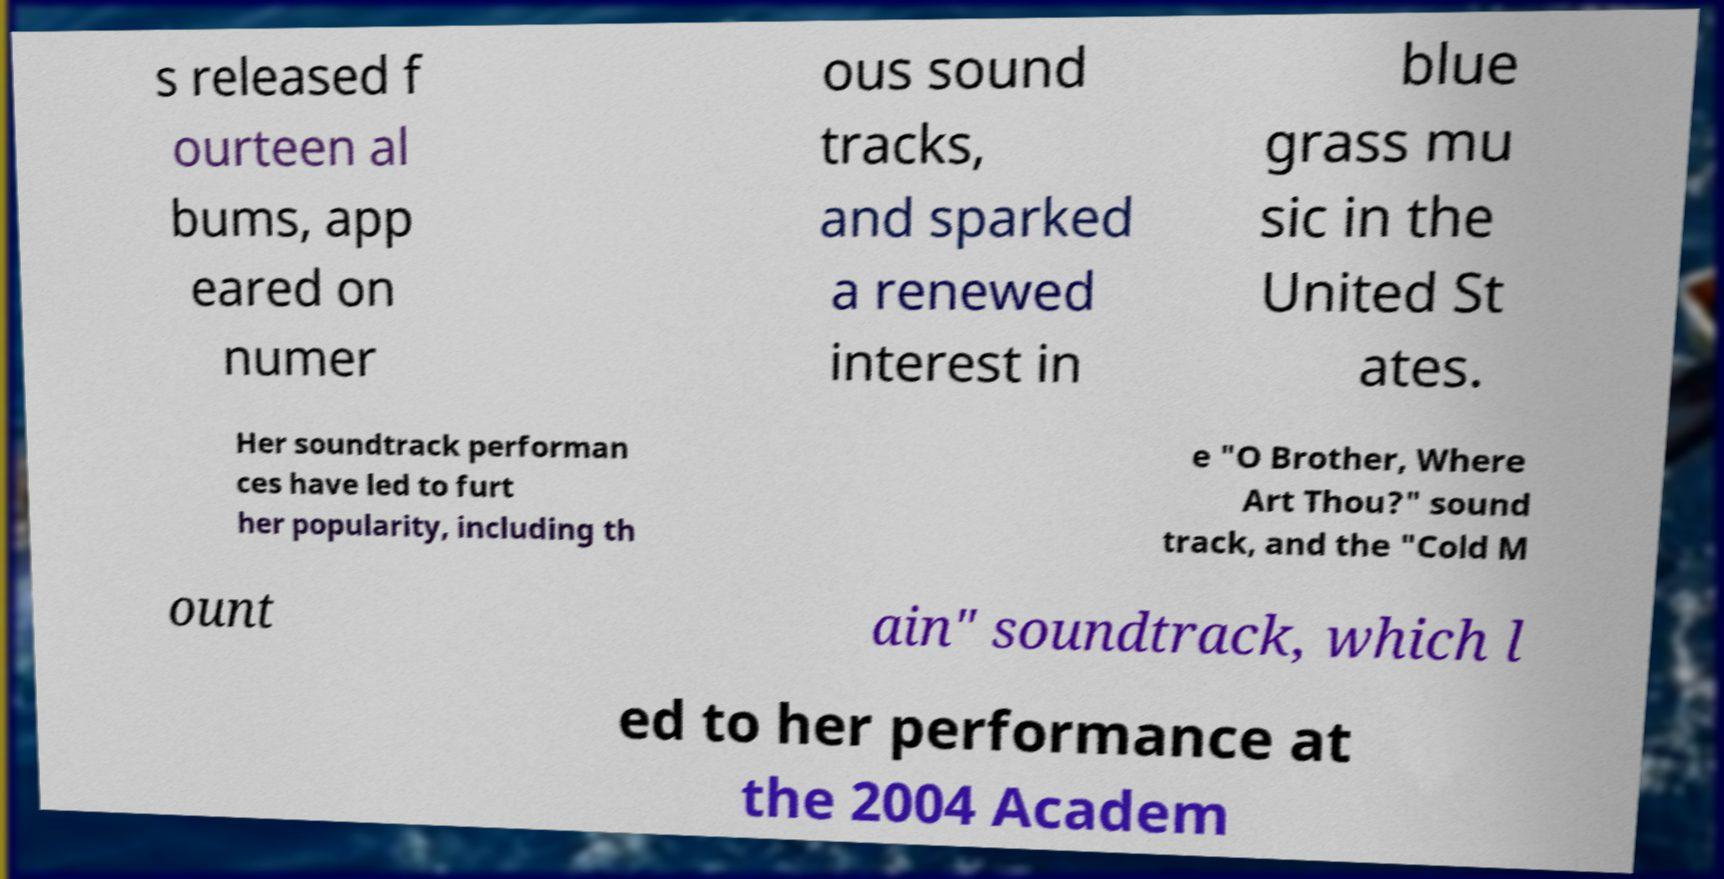Could you assist in decoding the text presented in this image and type it out clearly? s released f ourteen al bums, app eared on numer ous sound tracks, and sparked a renewed interest in blue grass mu sic in the United St ates. Her soundtrack performan ces have led to furt her popularity, including th e "O Brother, Where Art Thou?" sound track, and the "Cold M ount ain" soundtrack, which l ed to her performance at the 2004 Academ 